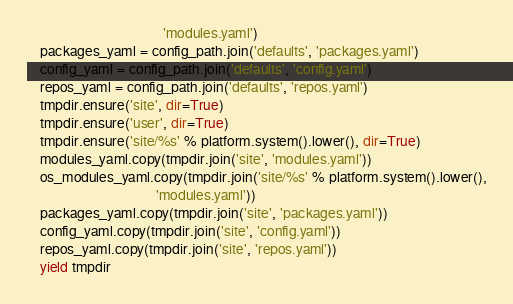<code> <loc_0><loc_0><loc_500><loc_500><_Python_>                                       'modules.yaml')
    packages_yaml = config_path.join('defaults', 'packages.yaml')
    config_yaml = config_path.join('defaults', 'config.yaml')
    repos_yaml = config_path.join('defaults', 'repos.yaml')
    tmpdir.ensure('site', dir=True)
    tmpdir.ensure('user', dir=True)
    tmpdir.ensure('site/%s' % platform.system().lower(), dir=True)
    modules_yaml.copy(tmpdir.join('site', 'modules.yaml'))
    os_modules_yaml.copy(tmpdir.join('site/%s' % platform.system().lower(),
                                     'modules.yaml'))
    packages_yaml.copy(tmpdir.join('site', 'packages.yaml'))
    config_yaml.copy(tmpdir.join('site', 'config.yaml'))
    repos_yaml.copy(tmpdir.join('site', 'repos.yaml'))
    yield tmpdir</code> 